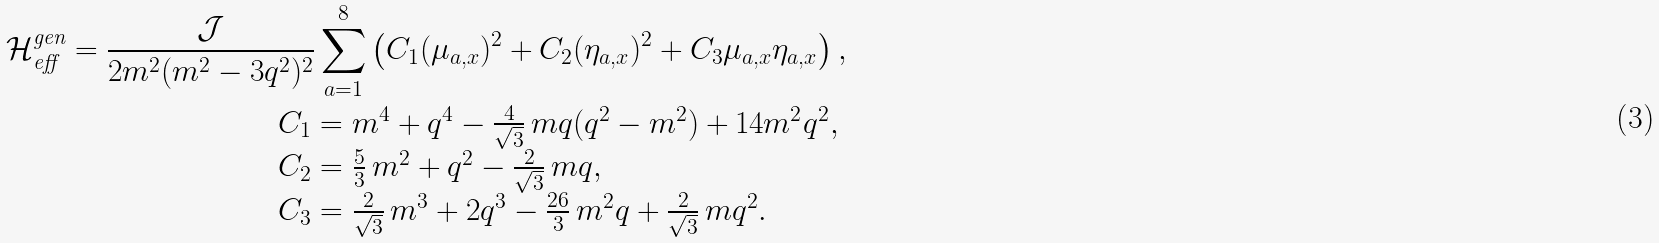Convert formula to latex. <formula><loc_0><loc_0><loc_500><loc_500>\mathcal { H } _ { \text {eff} } ^ { \text {gen} } = \frac { \mathcal { J } } { 2 m ^ { 2 } ( m ^ { 2 } - 3 q ^ { 2 } ) ^ { 2 } } \sum _ { a = 1 } ^ { 8 } \left ( C _ { 1 } ( \mu _ { a , x } ) ^ { 2 } + C _ { 2 } ( \eta _ { a , x } ) ^ { 2 } + C _ { 3 } \mu _ { a , x } \eta _ { a , x } \right ) , \\ \begin{array} { l } C _ { 1 } = m ^ { 4 } + q ^ { 4 } - \frac { 4 } { \sqrt { 3 } } \, m q ( q ^ { 2 } - m ^ { 2 } ) + 1 4 m ^ { 2 } q ^ { 2 } , \\ C _ { 2 } = \frac { 5 } { 3 } \, m ^ { 2 } + q ^ { 2 } - \frac { 2 } { \sqrt { 3 } } \, m q , \\ C _ { 3 } = \frac { 2 } { \sqrt { 3 } } \, m ^ { 3 } + 2 q ^ { 3 } - \frac { 2 6 } { 3 } \, m ^ { 2 } q + \frac { 2 } { \sqrt { 3 } } \, m q ^ { 2 } . \end{array}</formula> 